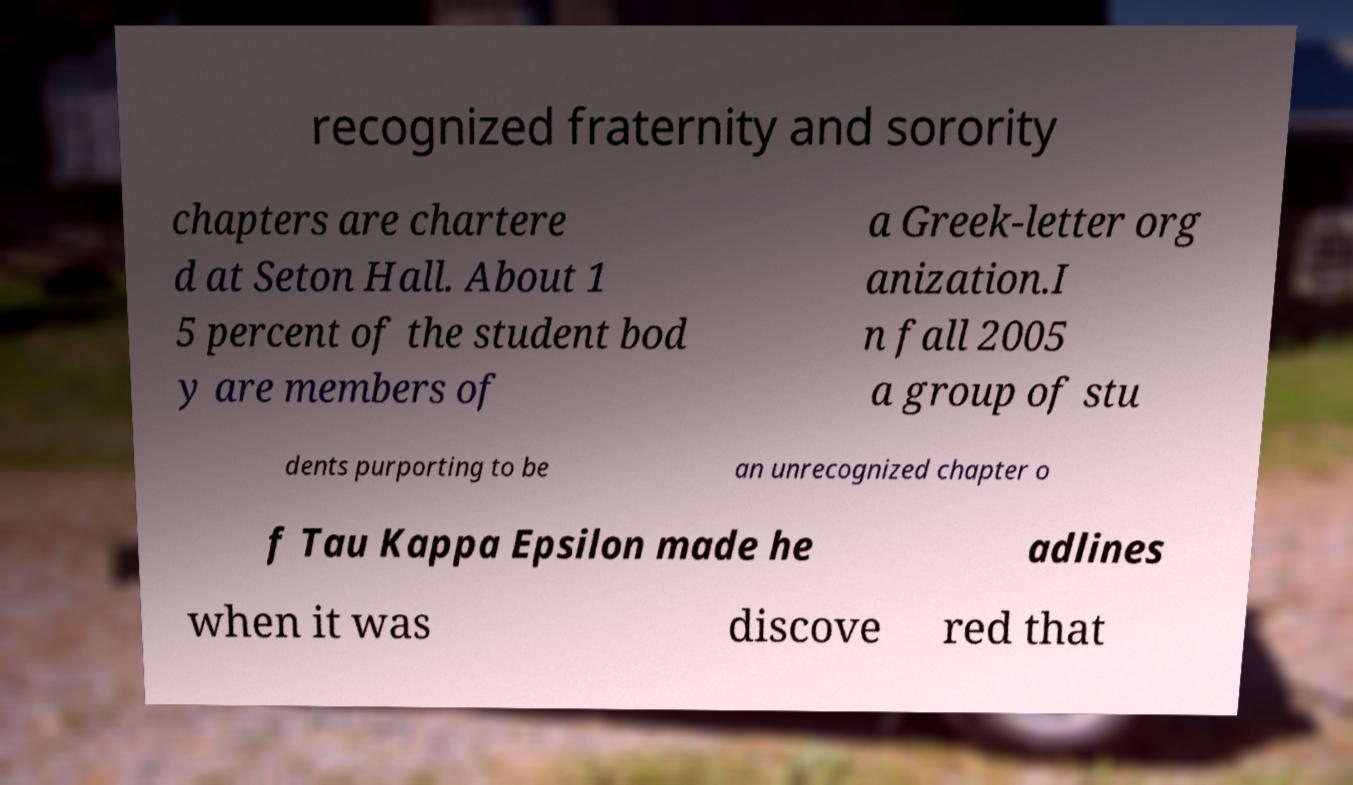What messages or text are displayed in this image? I need them in a readable, typed format. recognized fraternity and sorority chapters are chartere d at Seton Hall. About 1 5 percent of the student bod y are members of a Greek-letter org anization.I n fall 2005 a group of stu dents purporting to be an unrecognized chapter o f Tau Kappa Epsilon made he adlines when it was discove red that 